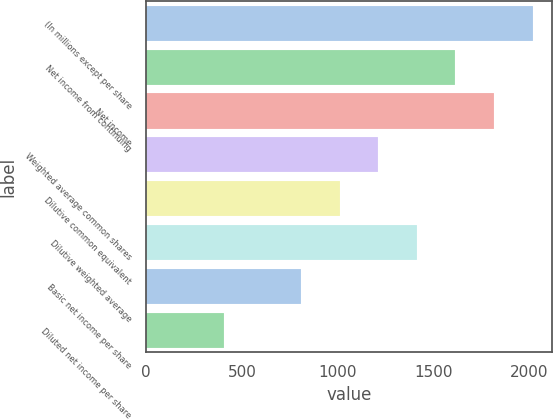Convert chart. <chart><loc_0><loc_0><loc_500><loc_500><bar_chart><fcel>(In millions except per share<fcel>Net income from continuing<fcel>Net income<fcel>Weighted average common shares<fcel>Dilutive common equivalent<fcel>Dilutive weighted average<fcel>Basic net income per share<fcel>Diluted net income per share<nl><fcel>2017<fcel>1614.2<fcel>1815.6<fcel>1211.4<fcel>1010<fcel>1412.8<fcel>808.6<fcel>405.8<nl></chart> 